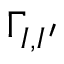Convert formula to latex. <formula><loc_0><loc_0><loc_500><loc_500>\Gamma _ { I , I ^ { \prime } }</formula> 